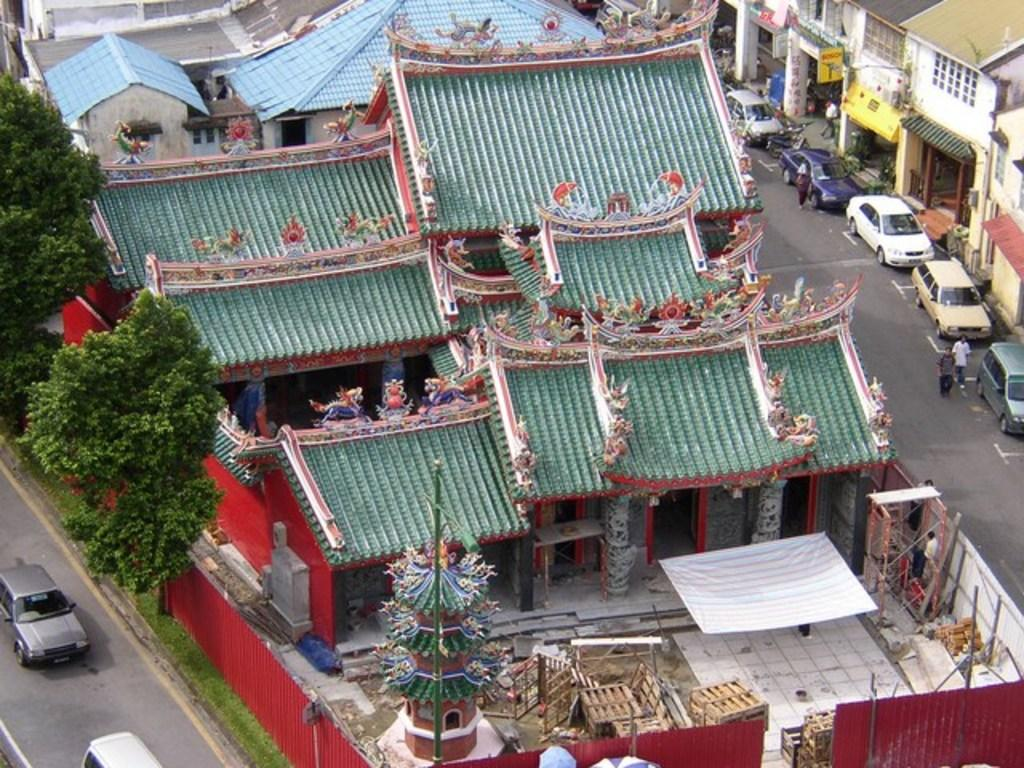What type of structures can be seen in the image? There are buildings in the image. What architectural features can be observed on the buildings? There are windows visible on the buildings. What signage is present in the image? There are name boards in the image. What type of vegetation is present in the image? There are trees in the image. What type of vertical structures can be seen in the image? There are poles in the image. What type of portable shelter is present in the image? There are umbrellas in the image. What type of barrier is present in the image? There is a fence in the image. What type of storage containers are present in the image? There are boxes in the image. What type of vehicles can be seen in the image? There are cars on the roads in the image. What type of human activity is depicted in the image? Some people are walking in the image. What color is the rose on the windowsill in the image? There is no rose present in the image. How much blood can be seen on the ground in the image? There is no blood present in the image. 